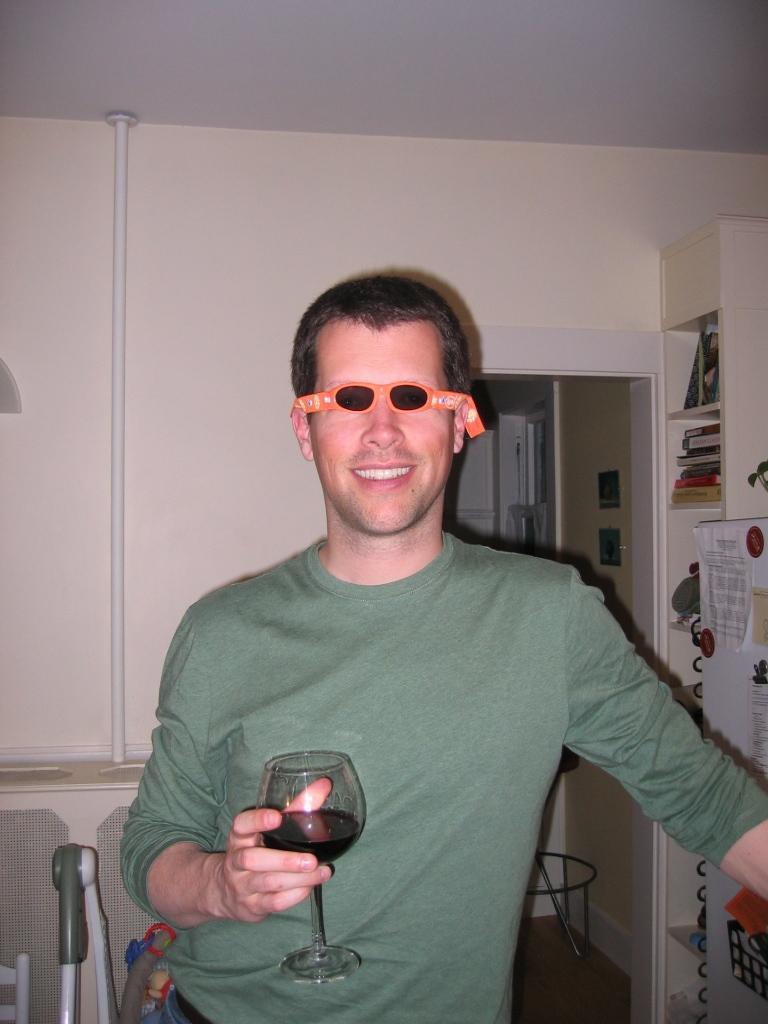How would you summarize this image in a sentence or two? In this picture we can see a man, he is smiling, he is wearing a glasses, and he is holding a glass in his hand, in the background we can find couple of books, hoarding, and a pipe and also we can see a wall. 